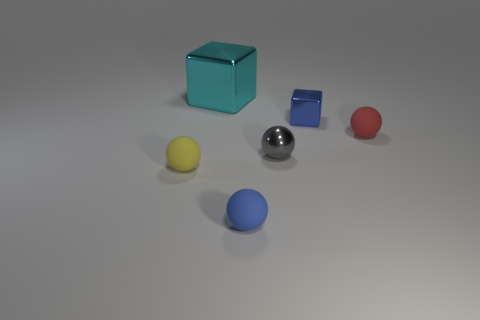Add 1 big gray metallic cubes. How many objects exist? 7 Subtract all spheres. How many objects are left? 2 Add 6 yellow blocks. How many yellow blocks exist? 6 Subtract 1 gray balls. How many objects are left? 5 Subtract all large cyan metallic blocks. Subtract all gray objects. How many objects are left? 4 Add 3 tiny blue shiny things. How many tiny blue shiny things are left? 4 